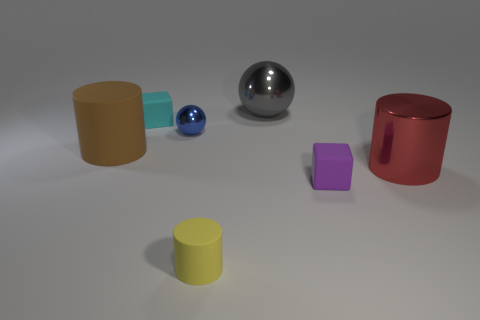Add 1 tiny purple metal spheres. How many objects exist? 8 Subtract all rubber cylinders. How many cylinders are left? 1 Subtract all cyan cubes. How many cubes are left? 1 Subtract 2 cylinders. How many cylinders are left? 1 Add 3 small blue things. How many small blue things exist? 4 Subtract 0 brown spheres. How many objects are left? 7 Subtract all spheres. How many objects are left? 5 Subtract all blue spheres. Subtract all purple blocks. How many spheres are left? 1 Subtract all yellow cylinders. How many cyan blocks are left? 1 Subtract all big gray spheres. Subtract all brown things. How many objects are left? 5 